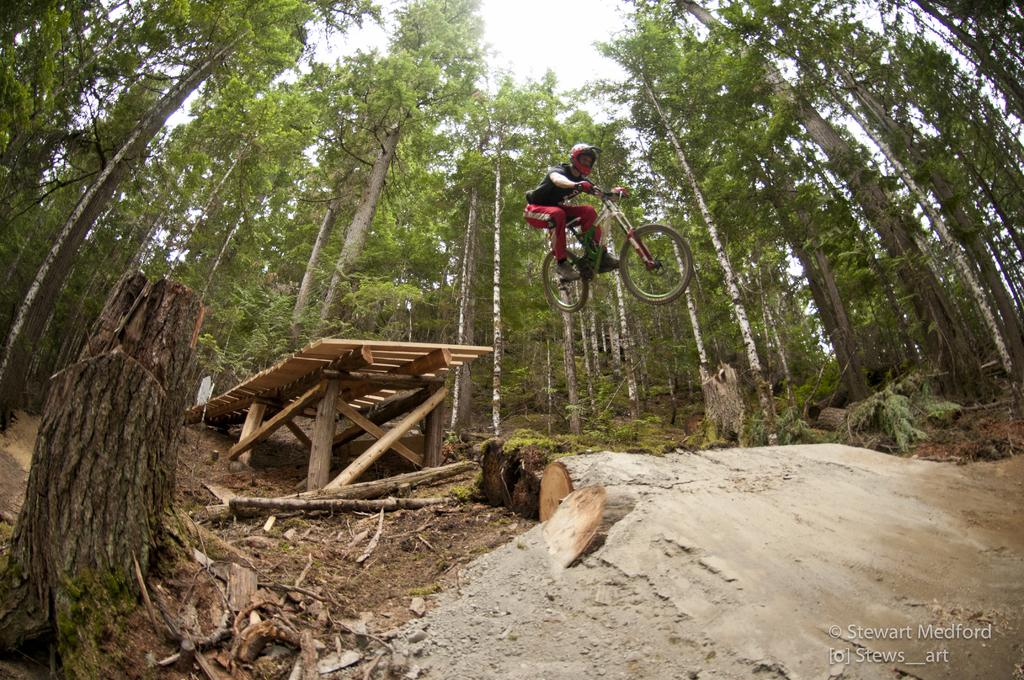What is the main subject of the image? There is a person riding a bicycle in the image. What is the person doing in the image? The person is in the air while riding the bicycle. What type of natural environment can be seen in the image? There are trees visible in the image. What is visible in the background of the image? The sky is visible in the background of the image. What type of window can be seen in the image? There is no window present in the image. How many books are visible in the image? There are no books visible in the image. 